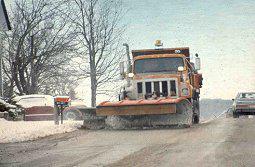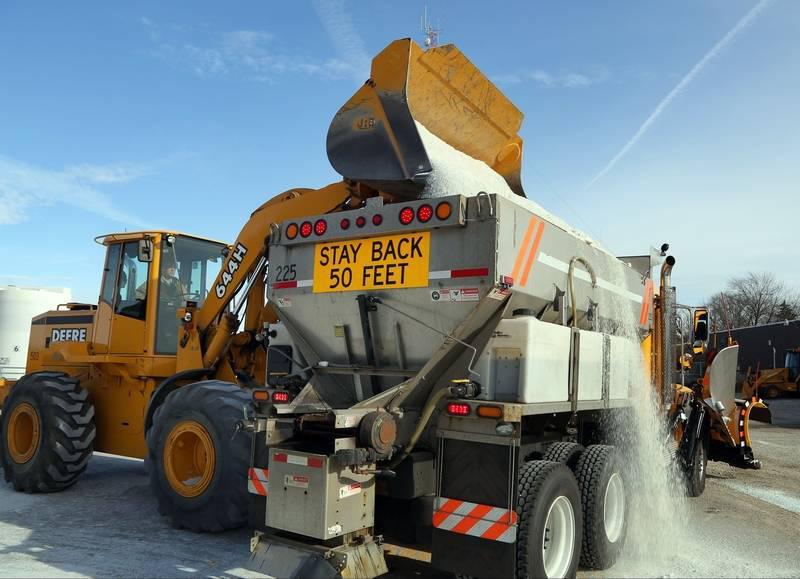The first image is the image on the left, the second image is the image on the right. Given the left and right images, does the statement "The left and right image contains the same number of snow scraper trucks plowing a road." hold true? Answer yes or no. No. The first image is the image on the left, the second image is the image on the right. Assess this claim about the two images: "There is a white vehicle.". Correct or not? Answer yes or no. No. 